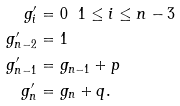<formula> <loc_0><loc_0><loc_500><loc_500>g _ { i } ^ { \prime } & = 0 \ \ 1 \leq i \leq n - 3 \\ g _ { n - 2 } ^ { \prime } & = 1 \\ g _ { n - 1 } ^ { \prime } & = g _ { n - 1 } + p \\ g _ { n } ^ { \prime } & = g _ { n } + q .</formula> 